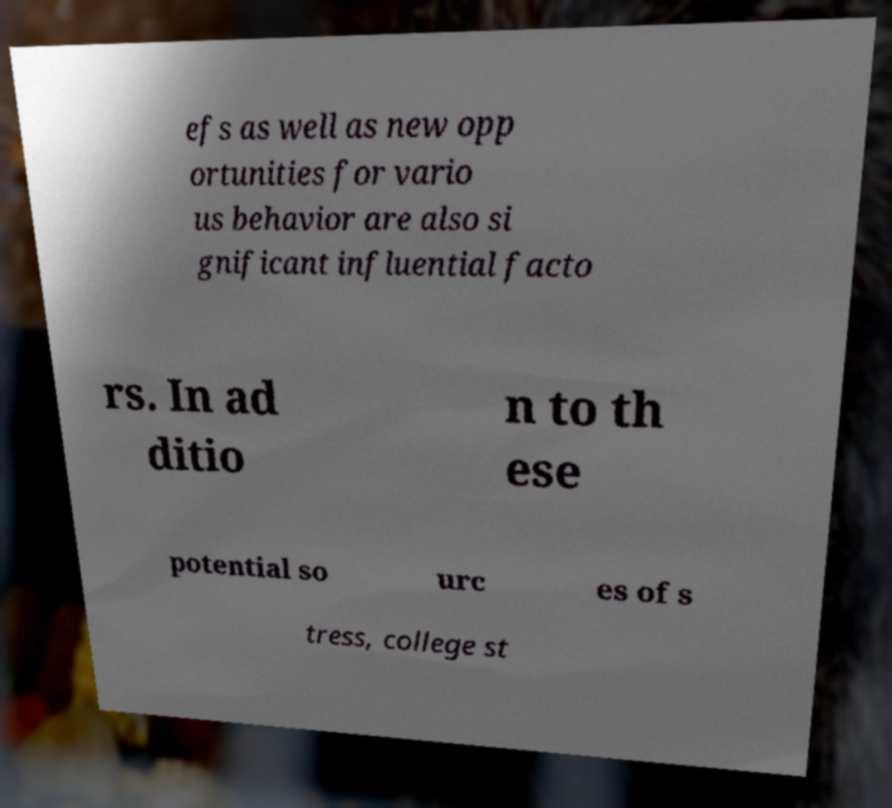For documentation purposes, I need the text within this image transcribed. Could you provide that? efs as well as new opp ortunities for vario us behavior are also si gnificant influential facto rs. In ad ditio n to th ese potential so urc es of s tress, college st 